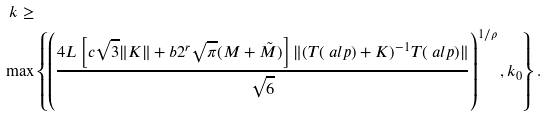<formula> <loc_0><loc_0><loc_500><loc_500>k \geq & \\ \, \max & \left \{ \left ( \frac { 4 L \left [ c \sqrt { 3 } \| K \| + b 2 ^ { r } \sqrt { \pi } ( M + \tilde { M } ) \right ] \| ( T ( \ a l p ) + K ) ^ { - 1 } T ( \ a l p ) \| } { \sqrt { 6 } } \right ) ^ { 1 / \rho } , k _ { 0 } \right \} .</formula> 